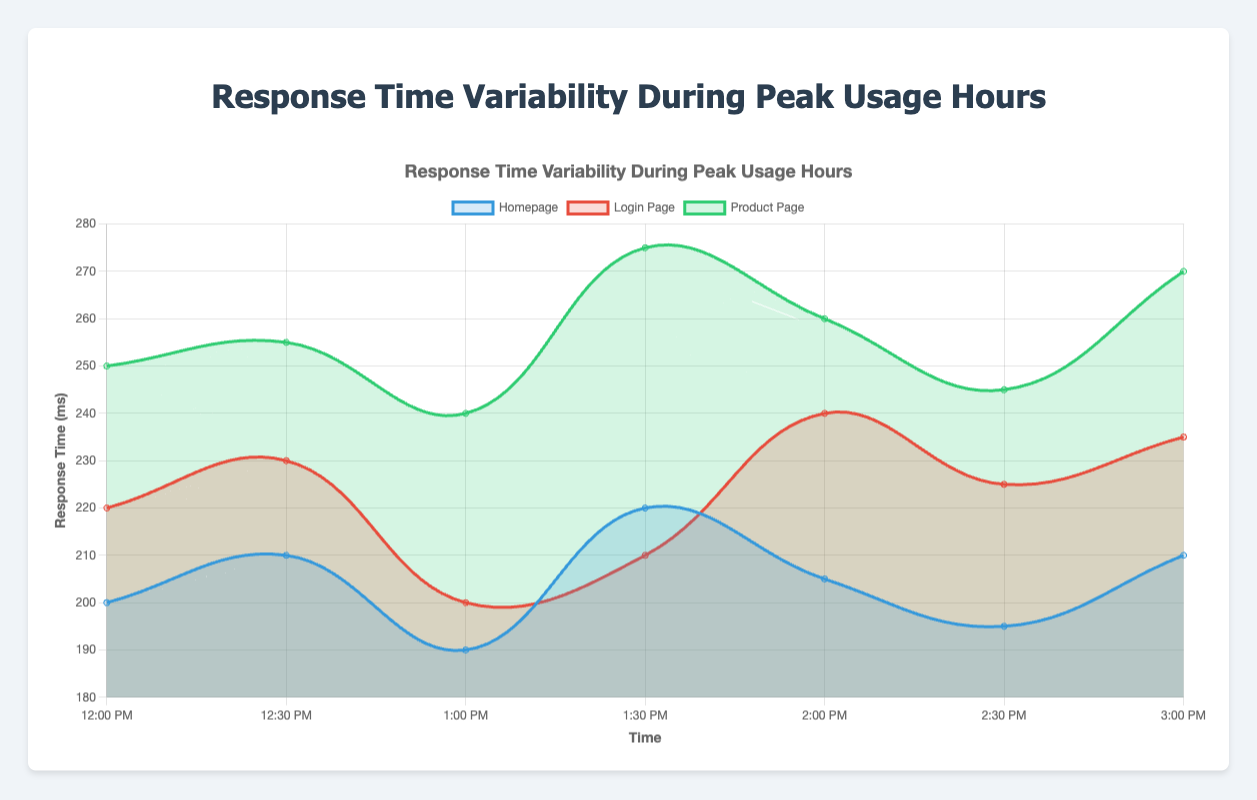Which page has the highest response time at 12:30 PM? The chart shows the response times by page and time. At 12:30 PM, the Product Page has the highest response time, highlighted in green, at 255 ms.
Answer: Product Page What is the difference in response time between the Homepage and Login Page at 1:00 PM? Look at the response times for the Homepage and Login Page at 1:00 PM. The Homepage has a response time of 190 ms, and the Login Page has 200 ms. Calculating the difference: 200 ms - 190 ms = 10 ms.
Answer: 10 ms Which page shows the greatest variability in response times across the entire period? By examining the different lines, you notice the fluctuations in the response times. The Product Page (green line) shows the most significant changes, indicating the highest variability.
Answer: Product Page During which time period does the Homepage have the lowest response time? Observing the points along the graph for the Homepage, the lowest response time occurs at 1:00 PM with a value of 190 ms.
Answer: 1:00 PM What is the average response time for the Login Page from 12:00 PM to 3:00 PM? Sum the response times for the Login Page (220, 230, 200, 210, 240, 225, 235) and divide by the number of entries. Average = (220 + 230 + 200 + 210 + 240 + 225 + 235) / 7 ≈ 223.57 ms.
Answer: 223.57 ms Does the response time for any page exceed 270 ms? Check all data points across the graph for each page. The Product Page has a response time of 275 ms at 1:30 PM, which is the only time it exceeds 270 ms.
Answer: Yes Which page consistently maintained a response time above 200 ms throughout the observed period? Examine each page's line to see if it is always above 200 ms. Both the Login Page and Product Page lines remain above 200 ms across all time points.
Answer: Login Page, Product Page At what time does the Login Page show its peak response time? The Login Page (red line) reaches its peak response time at 2:00 PM with a value of 240 ms.
Answer: 2:00 PM What is the difference between the highest and the lowest response times for the Product Page during the peak usage hours? Identify the highest (275 ms at 1:30 PM) and lowest (240 ms at 1:00 PM) response times for the Product Page. The difference is 275 ms - 240 ms = 35 ms.
Answer: 35 ms 